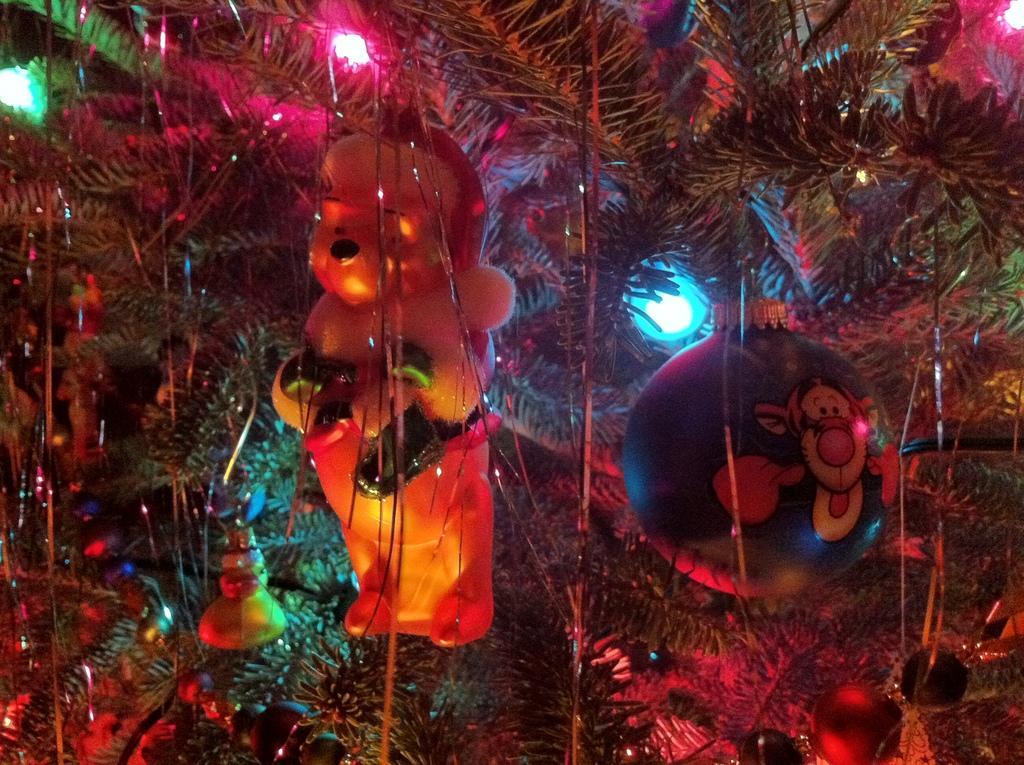Could you give a brief overview of what you see in this image? In the center of this picture we can see the toys and some balls and some decoration items are hanging on the tree and we can see the lights and some other objects. 